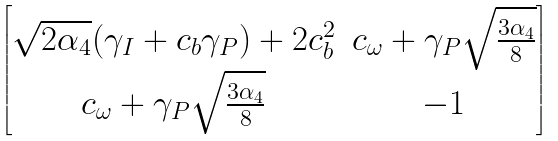Convert formula to latex. <formula><loc_0><loc_0><loc_500><loc_500>\begin{bmatrix} \sqrt { 2 \alpha _ { 4 } } ( \gamma _ { I } + c _ { b } \gamma _ { P } ) + 2 c _ { b } ^ { 2 } & c _ { \omega } + \gamma _ { P } \sqrt { \frac { 3 \alpha _ { 4 } } { 8 } } \\ c _ { \omega } + \gamma _ { P } \sqrt { \frac { 3 \alpha _ { 4 } } { 8 } } & - 1 \end{bmatrix}</formula> 